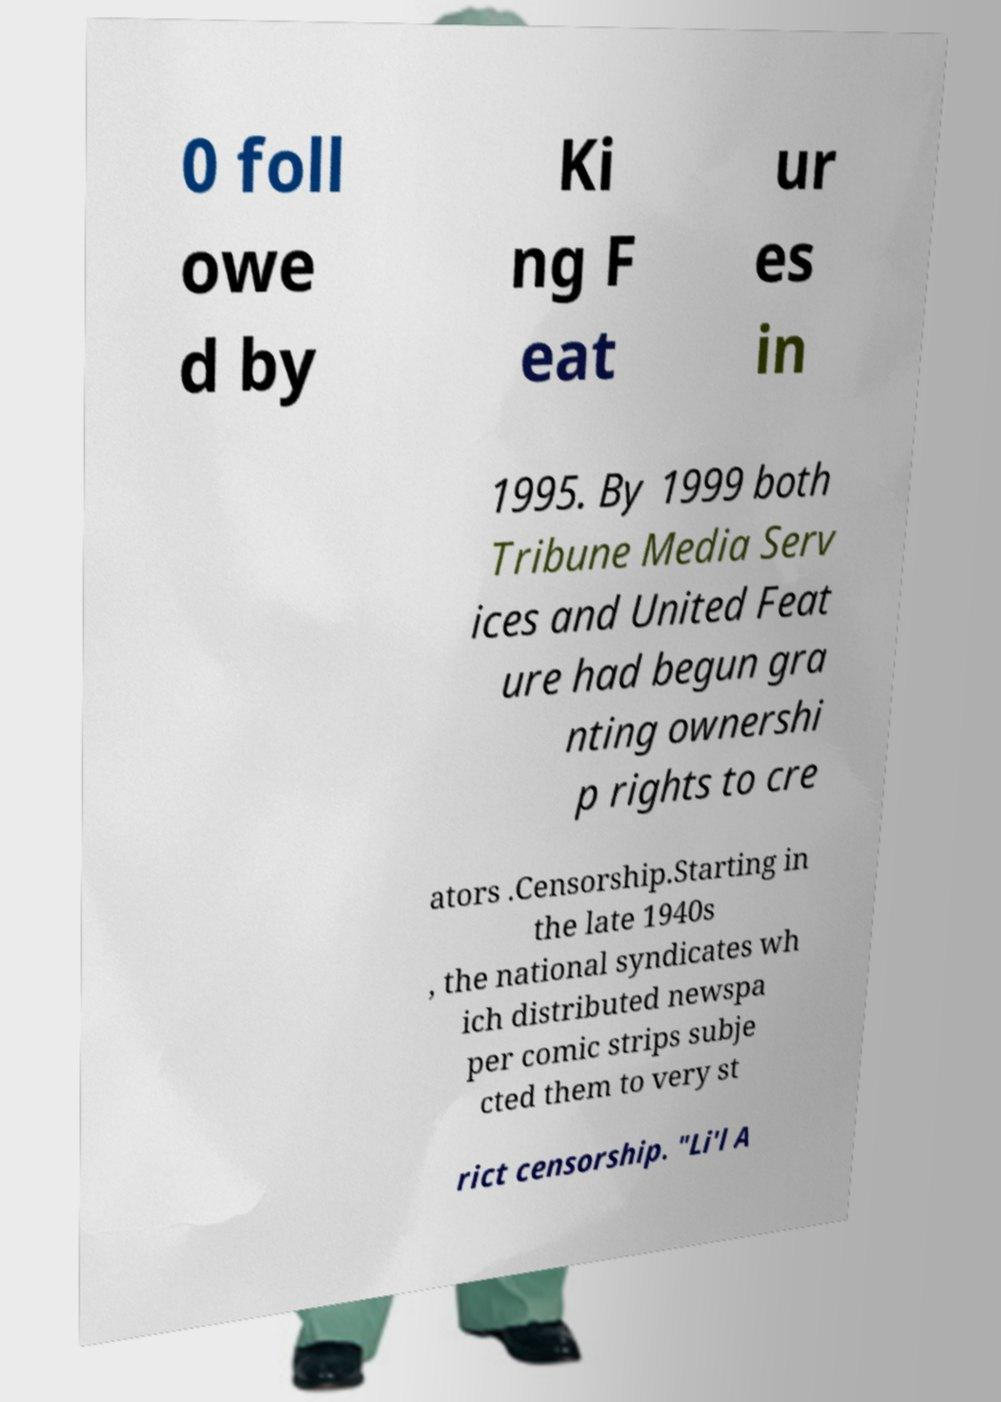Can you accurately transcribe the text from the provided image for me? 0 foll owe d by Ki ng F eat ur es in 1995. By 1999 both Tribune Media Serv ices and United Feat ure had begun gra nting ownershi p rights to cre ators .Censorship.Starting in the late 1940s , the national syndicates wh ich distributed newspa per comic strips subje cted them to very st rict censorship. "Li'l A 